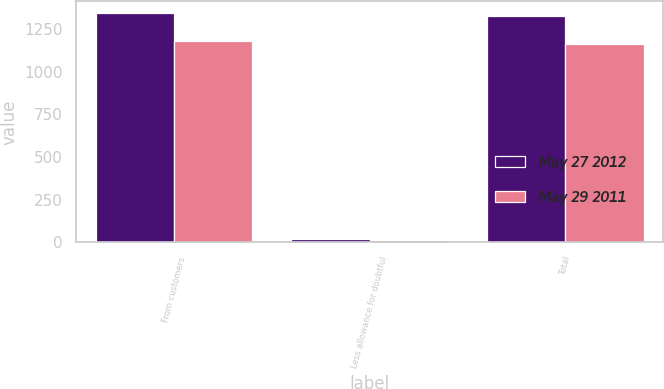Convert chart. <chart><loc_0><loc_0><loc_500><loc_500><stacked_bar_chart><ecel><fcel>From customers<fcel>Less allowance for doubtful<fcel>Total<nl><fcel>May 27 2012<fcel>1345.3<fcel>21.7<fcel>1323.6<nl><fcel>May 29 2011<fcel>1178.6<fcel>16.3<fcel>1162.3<nl></chart> 